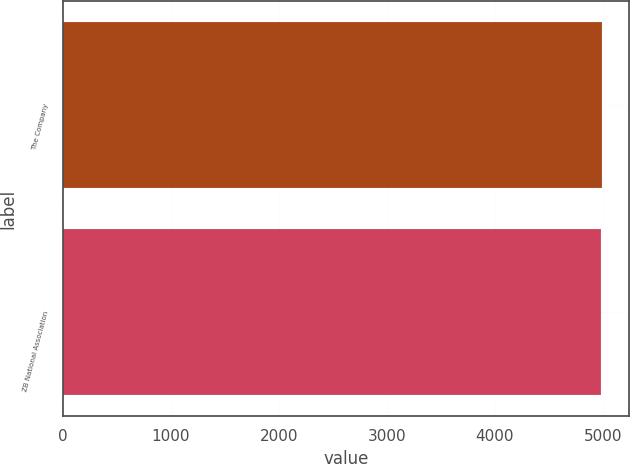Convert chart. <chart><loc_0><loc_0><loc_500><loc_500><bar_chart><fcel>The Company<fcel>ZB National Association<nl><fcel>4994<fcel>4983<nl></chart> 